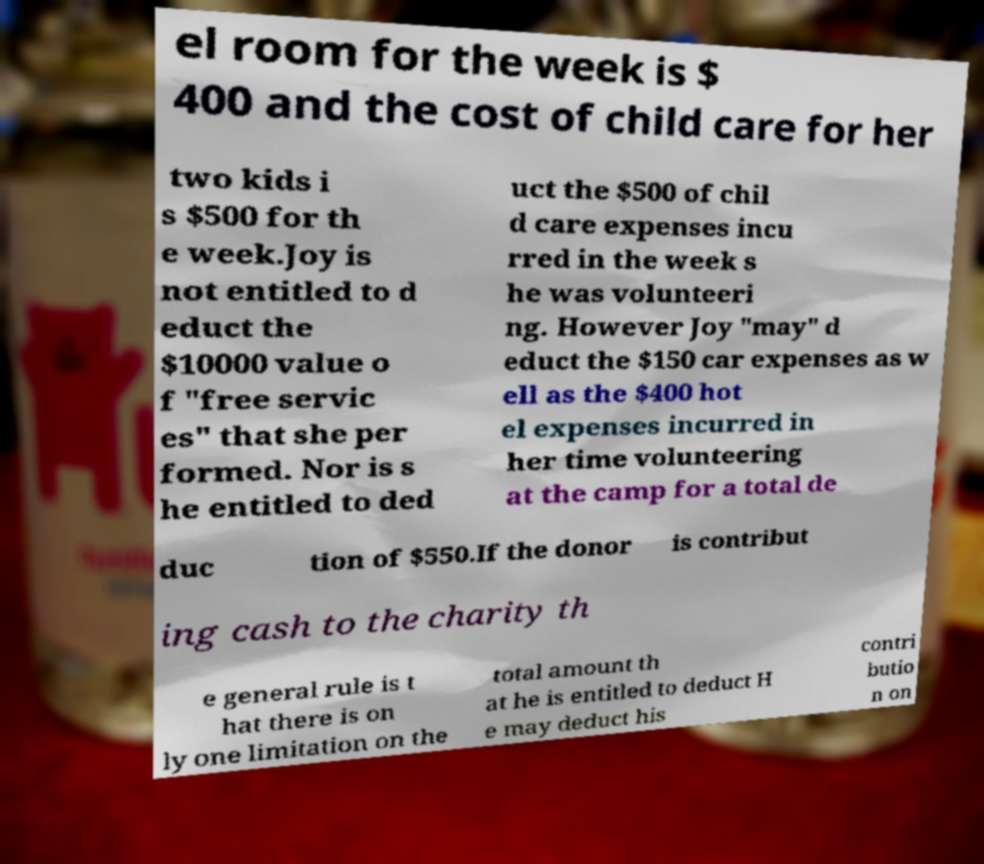Can you accurately transcribe the text from the provided image for me? el room for the week is $ 400 and the cost of child care for her two kids i s $500 for th e week.Joy is not entitled to d educt the $10000 value o f "free servic es" that she per formed. Nor is s he entitled to ded uct the $500 of chil d care expenses incu rred in the week s he was volunteeri ng. However Joy "may" d educt the $150 car expenses as w ell as the $400 hot el expenses incurred in her time volunteering at the camp for a total de duc tion of $550.If the donor is contribut ing cash to the charity th e general rule is t hat there is on ly one limitation on the total amount th at he is entitled to deduct H e may deduct his contri butio n on 